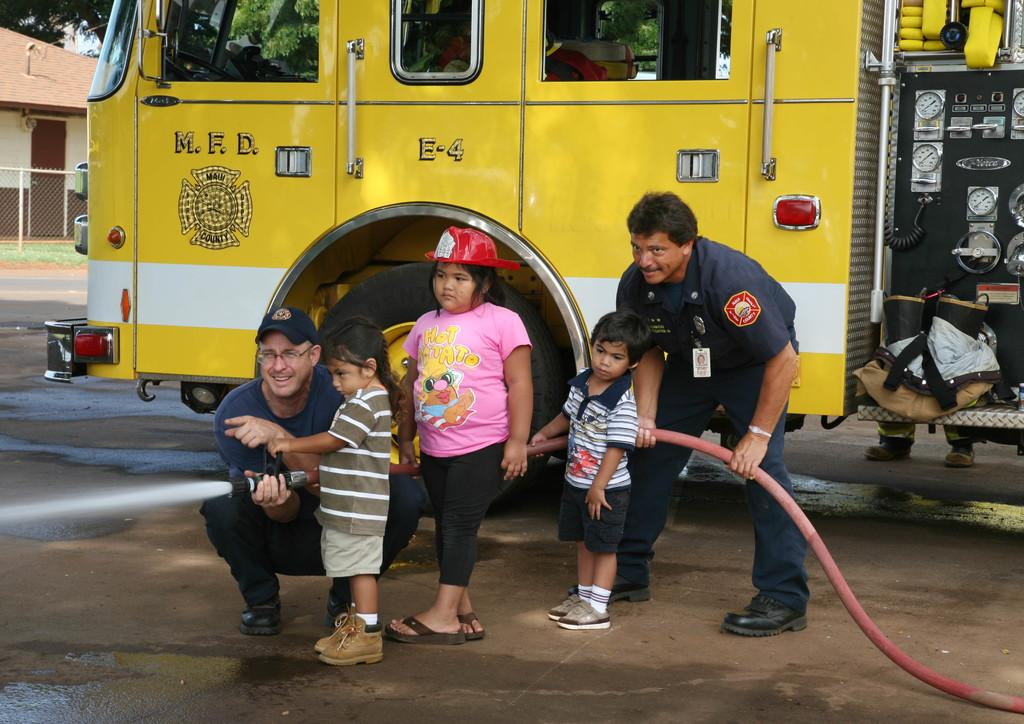How many people are in the foreground of the image? There are five persons in the foreground of the image. Where are the persons located in the image? The persons are on the road. What can be seen in the background of the image? There is a vehicle, a fence, grass, a house, and trees in the background of the image. When was the image taken? The image was taken during the day. What type of crate is being used to start the vehicle in the image? There is no crate or vehicle starting activity present in the image. What is the value of the house in the background of the image? The value of the house cannot be determined from the image. 